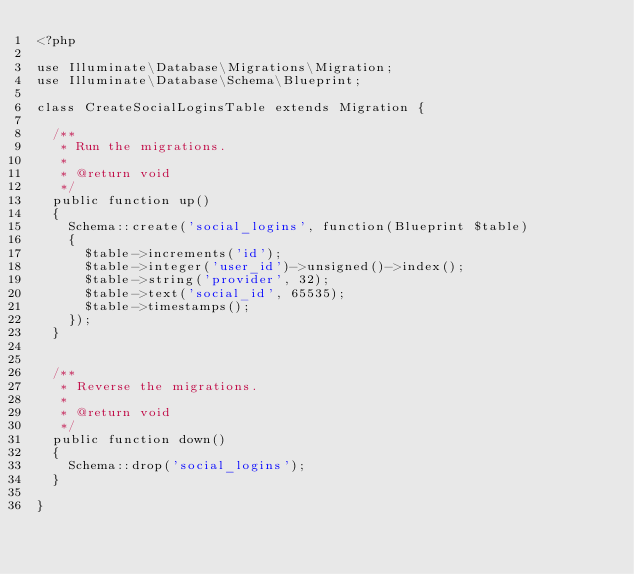<code> <loc_0><loc_0><loc_500><loc_500><_PHP_><?php

use Illuminate\Database\Migrations\Migration;
use Illuminate\Database\Schema\Blueprint;

class CreateSocialLoginsTable extends Migration {

	/**
	 * Run the migrations.
	 *
	 * @return void
	 */
	public function up()
	{
		Schema::create('social_logins', function(Blueprint $table)
		{
			$table->increments('id');
			$table->integer('user_id')->unsigned()->index();
			$table->string('provider', 32);
			$table->text('social_id', 65535);
			$table->timestamps();
		});
	}


	/**
	 * Reverse the migrations.
	 *
	 * @return void
	 */
	public function down()
	{
		Schema::drop('social_logins');
	}

}
</code> 